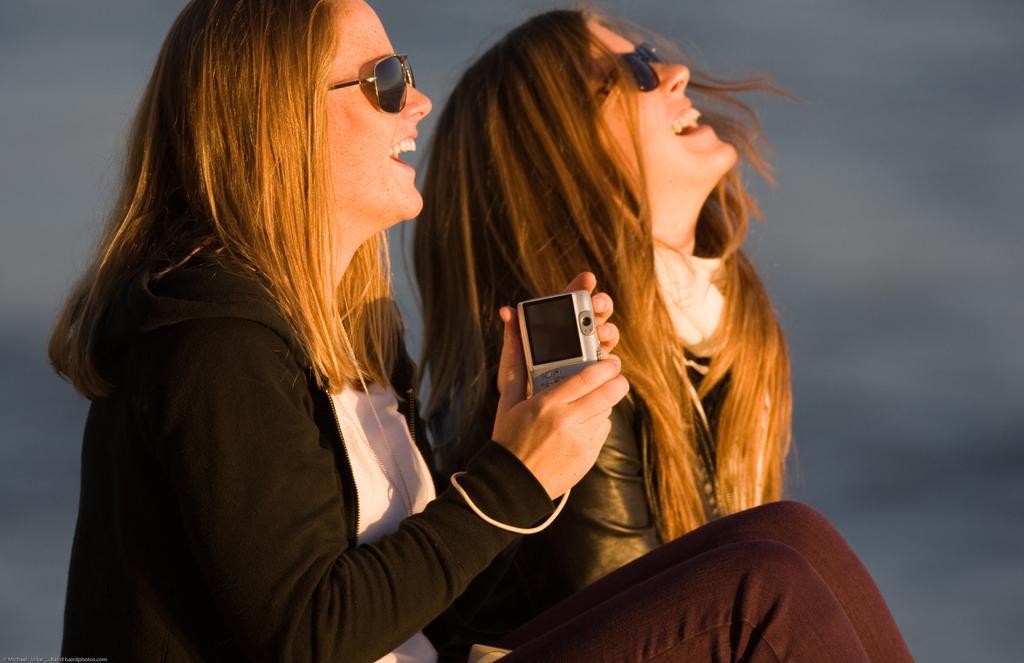Please provide a concise description of this image. This picture seems to be clicked outside. On the left there is a woman wearing black color jacket holding a camera, smiling and sitting and we can see another woman wearing black color dress, smiling and seems to be sitting. The background of the image is blurry. 